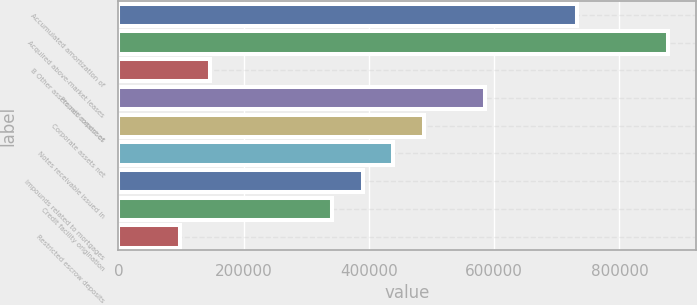Convert chart. <chart><loc_0><loc_0><loc_500><loc_500><bar_chart><fcel>Accumulated amortization of<fcel>Acquired above-market leases<fcel>B Other assets net consist of<fcel>Prepaid expenses<fcel>Corporate assets net<fcel>Notes receivable issued in<fcel>Impounds related to mortgages<fcel>Credit facility origination<fcel>Restricted escrow deposits<nl><fcel>731856<fcel>878211<fcel>146440<fcel>585502<fcel>487933<fcel>439148<fcel>390364<fcel>341579<fcel>97655.4<nl></chart> 